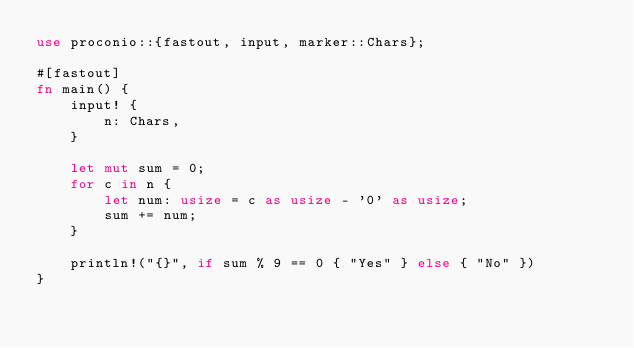Convert code to text. <code><loc_0><loc_0><loc_500><loc_500><_Rust_>use proconio::{fastout, input, marker::Chars};

#[fastout]
fn main() {
    input! {
        n: Chars,
    }

    let mut sum = 0;
    for c in n {
        let num: usize = c as usize - '0' as usize;
        sum += num;
    }

    println!("{}", if sum % 9 == 0 { "Yes" } else { "No" })
}
</code> 